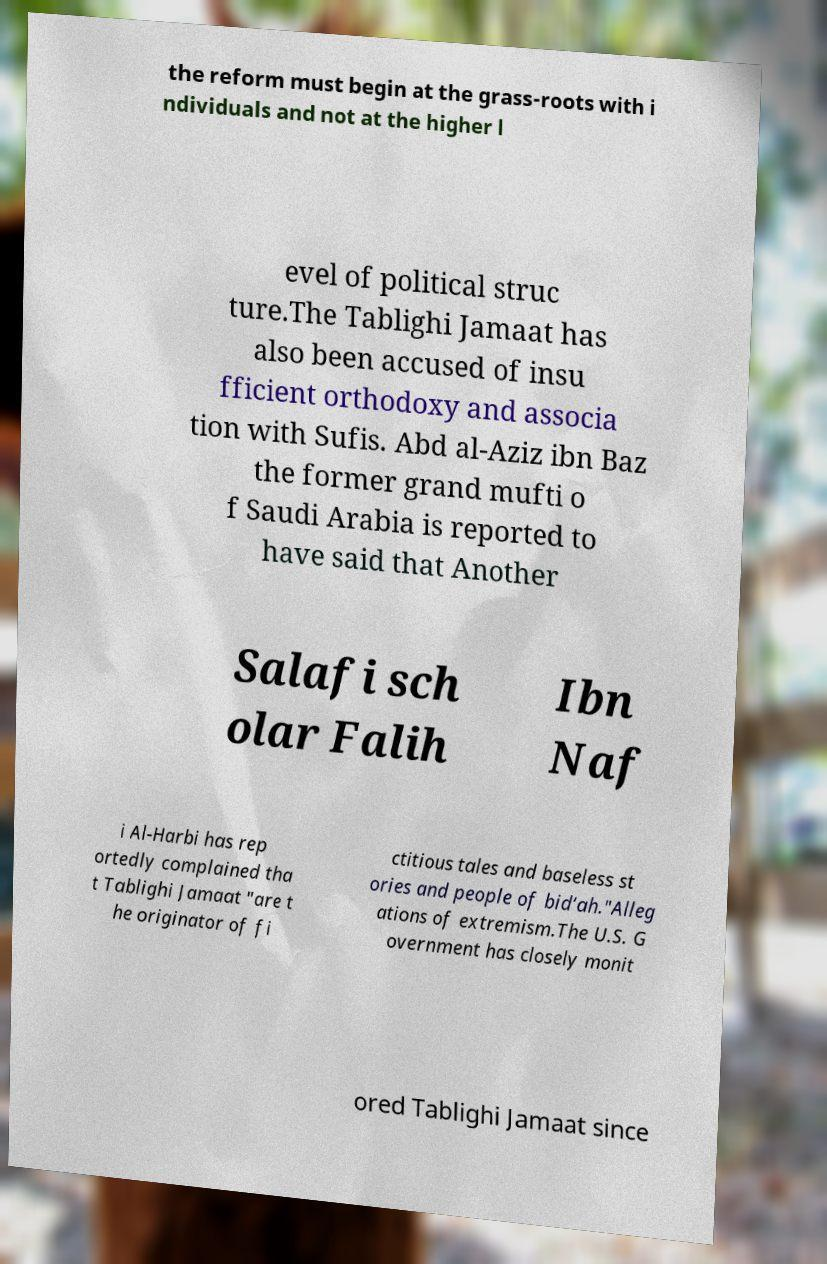Please read and relay the text visible in this image. What does it say? the reform must begin at the grass-roots with i ndividuals and not at the higher l evel of political struc ture.The Tablighi Jamaat has also been accused of insu fficient orthodoxy and associa tion with Sufis. Abd al-Aziz ibn Baz the former grand mufti o f Saudi Arabia is reported to have said that Another Salafi sch olar Falih Ibn Naf i Al-Harbi has rep ortedly complained tha t Tablighi Jamaat "are t he originator of fi ctitious tales and baseless st ories and people of bid‘ah."Alleg ations of extremism.The U.S. G overnment has closely monit ored Tablighi Jamaat since 